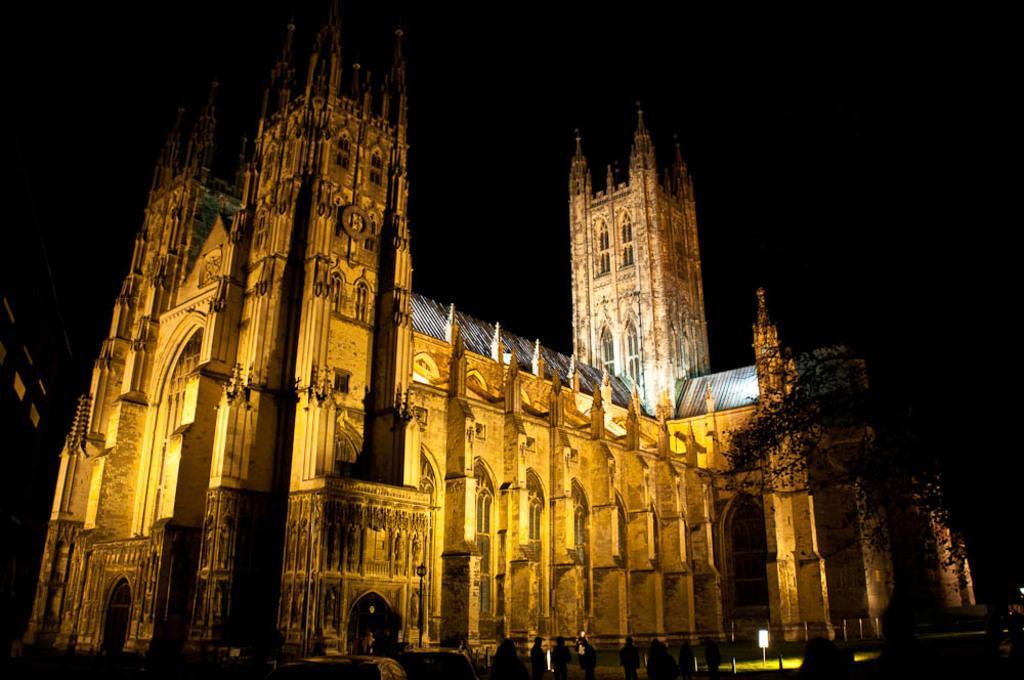Please provide a concise description of this image. In this image I can see a building, windows, few people, trees and the board. Background is black in color. 